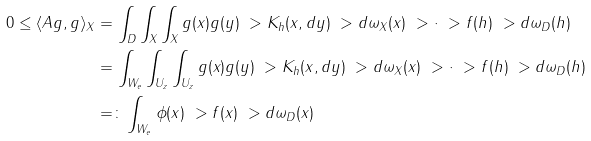<formula> <loc_0><loc_0><loc_500><loc_500>0 \leq \langle A g , g \rangle _ { X } & = \int _ { D } \int _ { X } \int _ { X } g ( x ) g ( y ) \ > K _ { h } ( x , d y ) \ > d \omega _ { X } ( x ) \ > \cdot \ > f ( h ) \ > d \omega _ { D } ( h ) \\ & = \int _ { W _ { e } } \int _ { U _ { z } } \int _ { U _ { z } } g ( x ) g ( y ) \ > K _ { h } ( x , d y ) \ > d \omega _ { X } ( x ) \ > \cdot \ > f ( h ) \ > d \omega _ { D } ( h ) \\ & = \colon \int _ { W _ { e } } \phi ( x ) \ > f ( x ) \ > d \omega _ { D } ( x )</formula> 